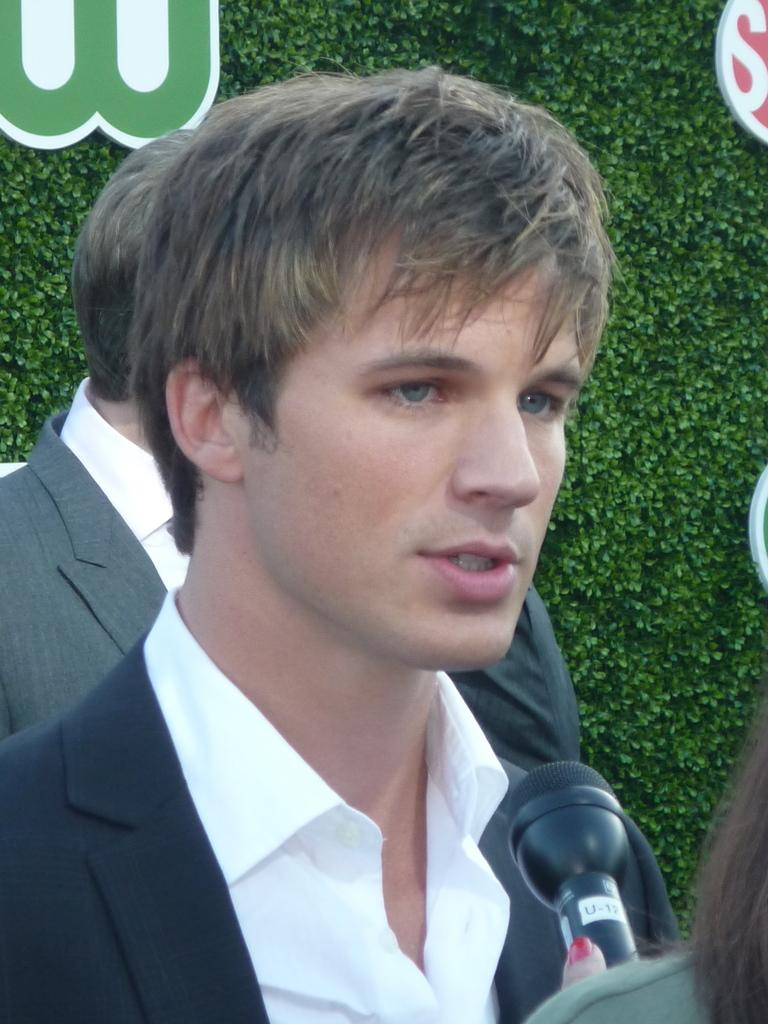How many people are in the image? There are two persons in the image. What are the persons wearing? The persons are wearing clothes. What object can be seen in the bottom right of the image? There is a mic in the bottom right of the image. What type of natural elements can be seen in the background of the image? There are leaves visible in the background of the image. What time of day is it in the image, and what type of fan can be seen? The time of day is not mentioned in the image, and there is no fan present. 